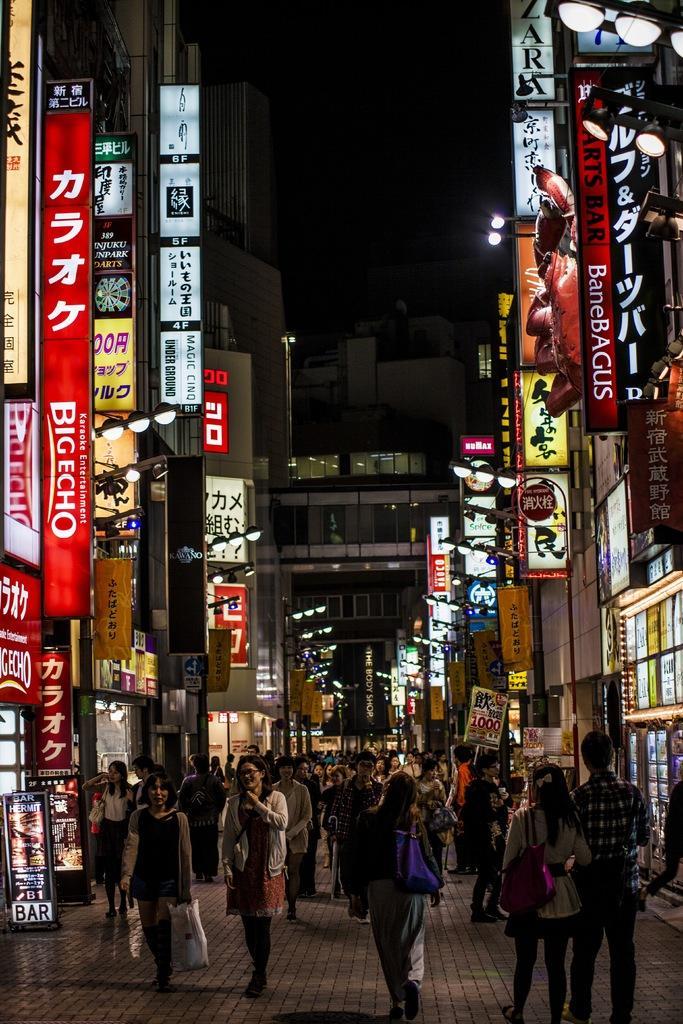Could you give a brief overview of what you see in this image? This is a picture of a city , where there are group of people standing, buildings, boards, light boards, and in the background there is sky. 